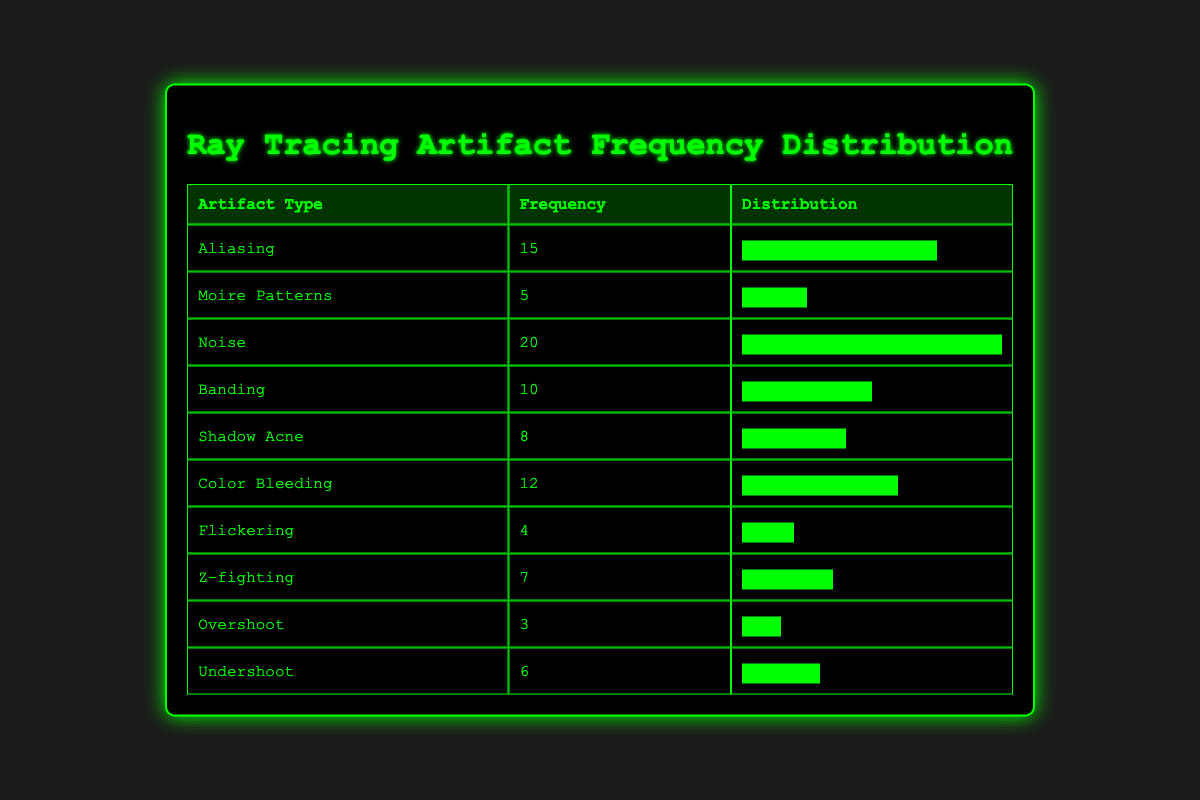What is the frequency of Noise? The table indicates that Noise has a frequency of 20, which is the highest among all artifact types.
Answer: 20 How many types of artifacts have a frequency greater than 10? By observing the table, we see that there are four types of artifacts with frequencies greater than 10: Noise (20), Aliasing (15), Color Bleeding (12), and Banding (10). However, only Noise, Aliasing, and Color Bleeding exceed 10. Thus, there are three types.
Answer: 3 What is the cumulative frequency of Shadow Acne and Z-fighting? The frequency of Shadow Acne is 8 and Z-fighting is 7. Adding these two values gives a cumulative frequency of 15 (8 + 7 = 15).
Answer: 15 Is it true that Color Bleeding's frequency is greater than Shadow Acne's frequency? Looking at the table, Color Bleeding has a frequency of 12, whereas Shadow Acne has a frequency of 8. Therefore, it is true that Color Bleeding's frequency is greater.
Answer: Yes Which artifact type has the lowest frequency, and what is its value? The lowest frequency in the table is associated with Overshoot, which has a frequency of 3.
Answer: Overshoot, 3 What is the average frequency of the artifacts listed in the table? To find the average, we first sum all the frequencies: 15 + 5 + 20 + 10 + 8 + 12 + 4 + 7 + 3 + 6 = 90. Then, divide by the number of artifact types, which is 10: 90 / 10 = 9.
Answer: 9 How many artifacts have a frequency of 6 or less? The artifacts with a frequency of 6 or less are Flickering (4), Overshoot (3), and Undershoot (6). Therefore, there are three artifacts that meet this condition.
Answer: 3 What is the difference in frequency between Noise and Moire Patterns? Noise has a frequency of 20, while Moire Patterns has a frequency of 5. The difference between them is 20 - 5 = 15.
Answer: 15 Are there more artifacts with frequencies in the range of 4 to 10 compared to those in the range of 0 to 4? In the range of 4 to 10, we have the following artifacts: Shadow Acne (8), Banding (10), Z-fighting (7), and Flickering (4), which total four artifacts. In the range of 0 to 4, there is only one artifact, Overshoot (3). Thus, there are more in the range of 4 to 10.
Answer: Yes 